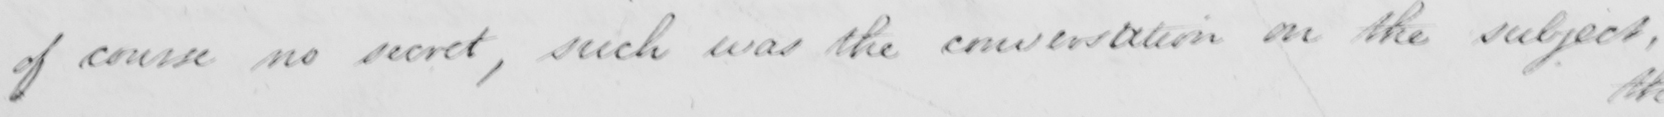Can you tell me what this handwritten text says? of course no secret , such was the conversation on the subject , 